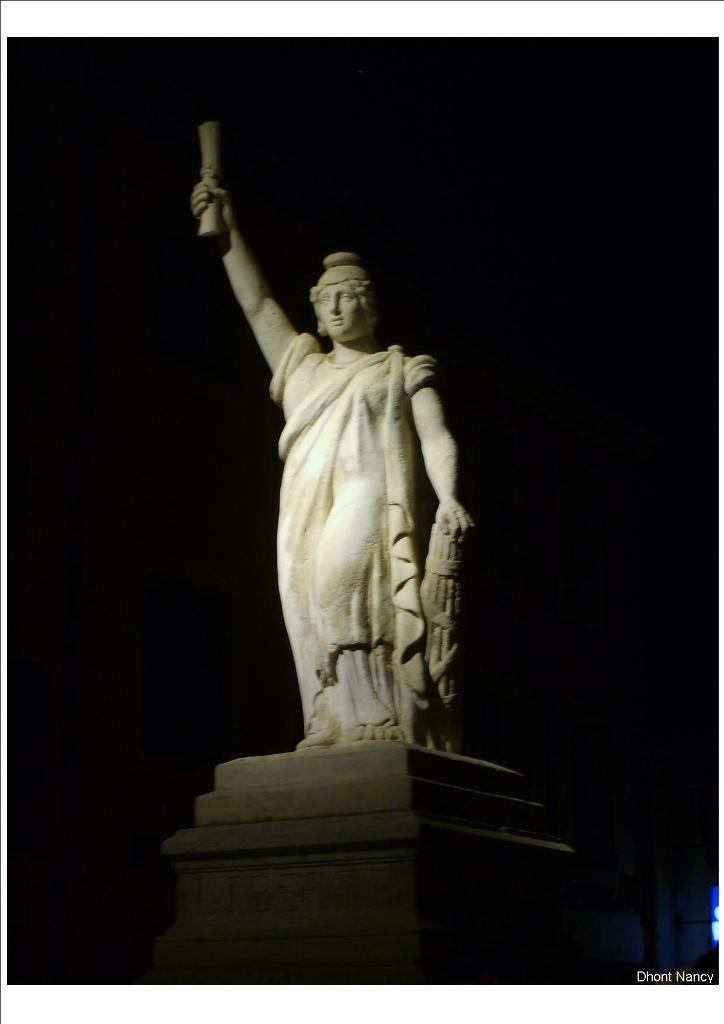What is the main subject of the image? There is a statue in the image. What is the color of the statue? The statue is white in color. What material is the statue made of? The statue is made of rock. How would you describe the background of the image? The background of the image is dark. What type of support can be seen holding up the statue in the image? There is no visible support holding up the statue in the image. How many things are present in the image? It is not possible to determine the exact number of things in the image based on the provided facts. 